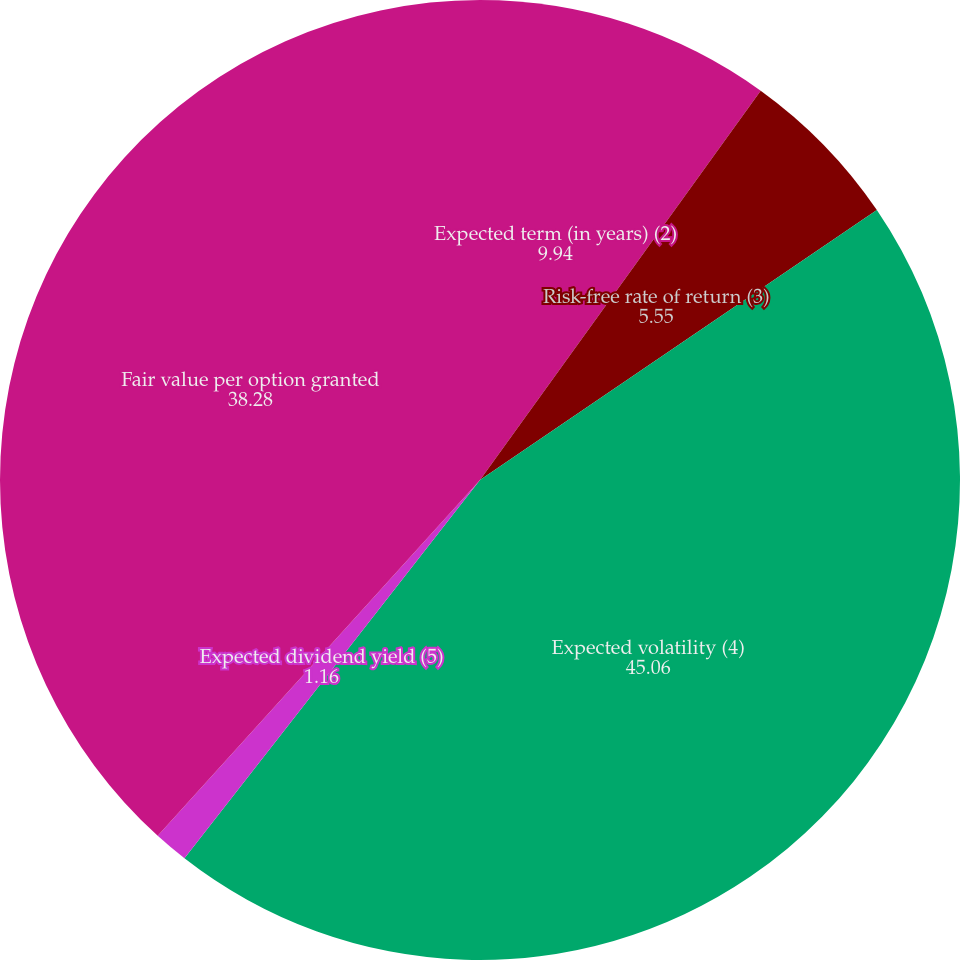Convert chart to OTSL. <chart><loc_0><loc_0><loc_500><loc_500><pie_chart><fcel>Expected term (in years) (2)<fcel>Risk-free rate of return (3)<fcel>Expected volatility (4)<fcel>Expected dividend yield (5)<fcel>Fair value per option granted<nl><fcel>9.94%<fcel>5.55%<fcel>45.06%<fcel>1.16%<fcel>38.28%<nl></chart> 